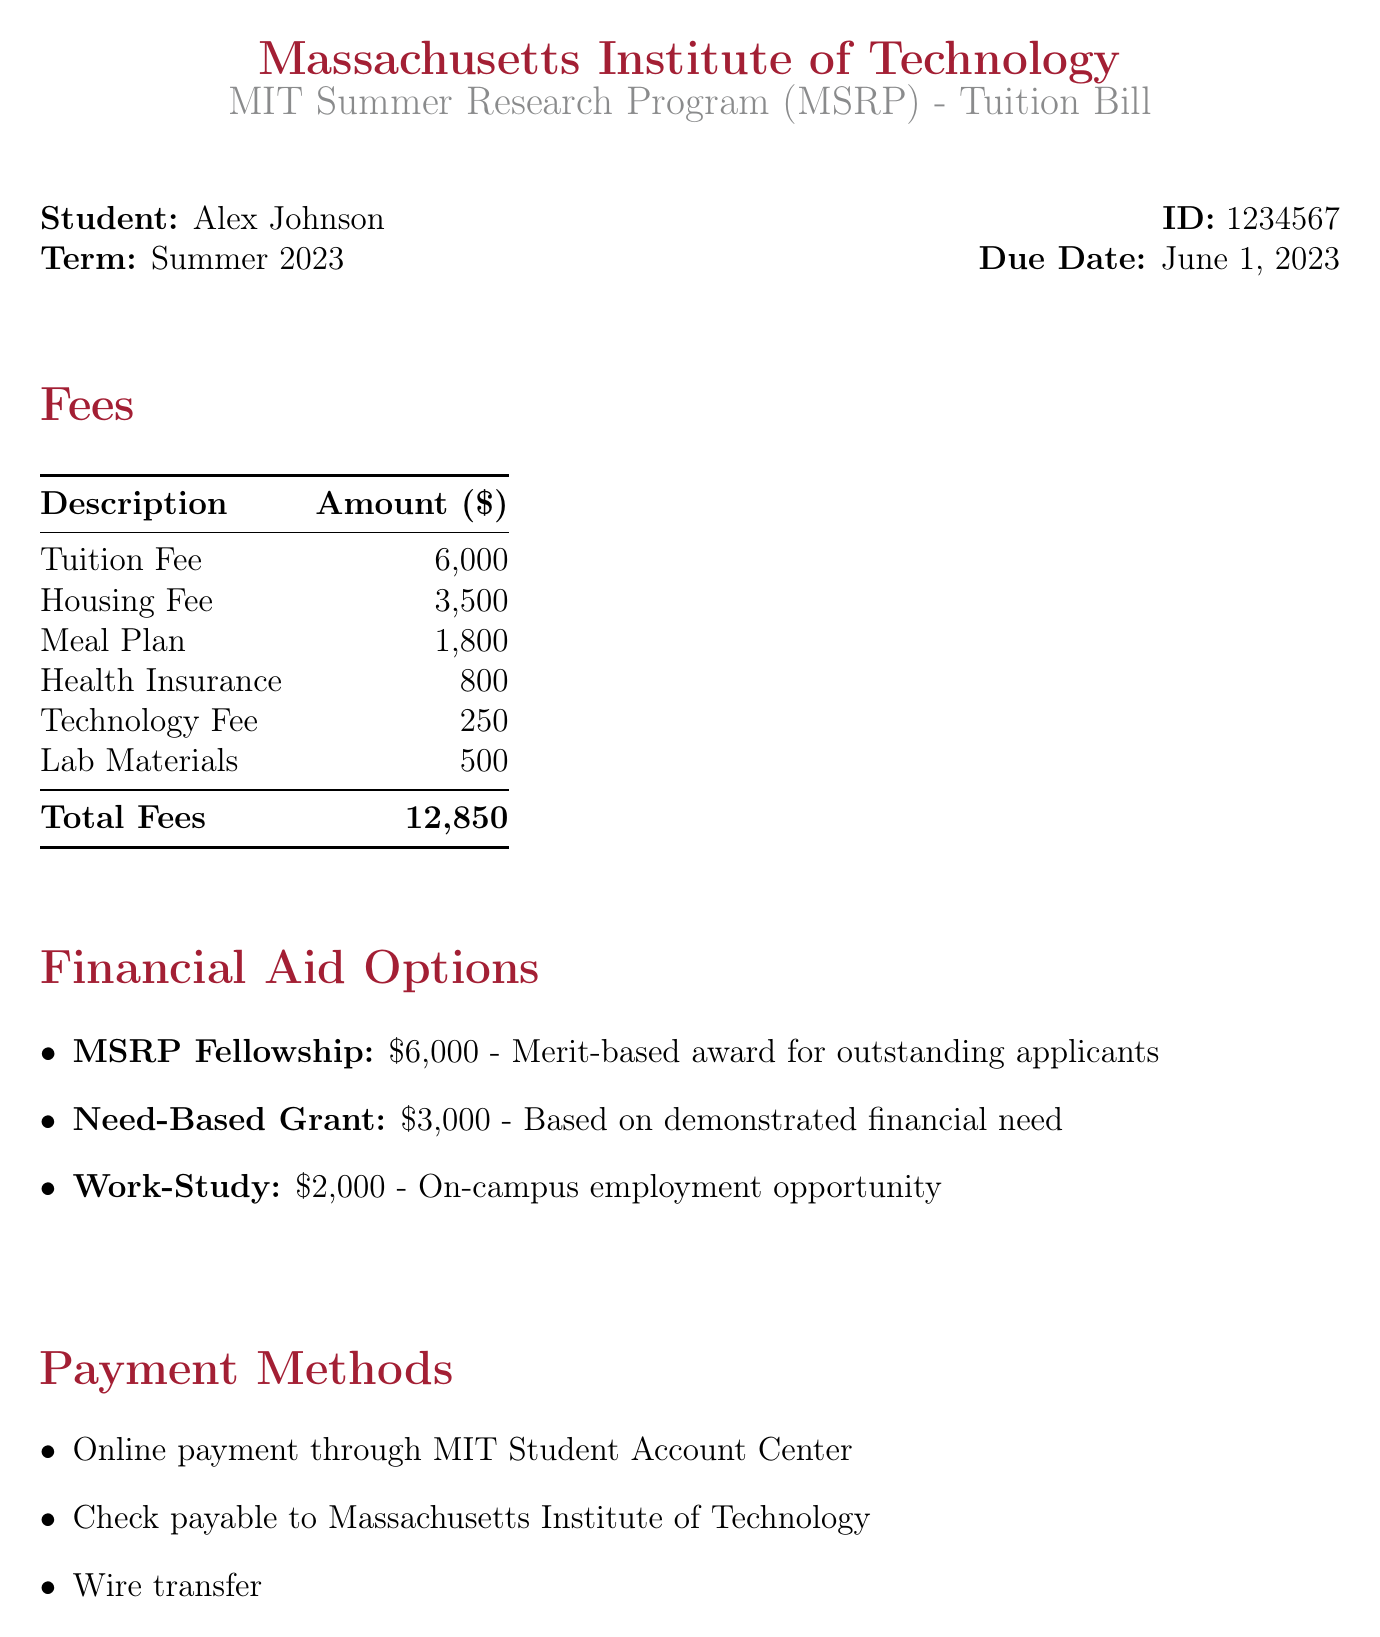What is the tuition fee? The tuition fee is listed directly in the document under "Fees."
Answer: 6000 What is the total amount of fees? This is represented in the "Total Fees" row of the Fees section.
Answer: 12850 What is the due date for the tuition bill? The due date is specified in the introductory section of the document.
Answer: June 1, 2023 What is the amount of the MSRP Fellowship? The MSRP Fellowship amount is mentioned under Financial Aid Options.
Answer: 6000 What is the purpose of the Need-Based Grant? The purpose is indicated in the description under Financial Aid Options, which mentions it is based on financial need.
Answer: Based on demonstrated financial need How can payments be made? The document lists methods for payments in the "Payment Methods" section.
Answer: Online payment, check, wire transfer How much can a student earn through Work-Study? The earning amount for Work-Study is indicated in the Financial Aid Options section.
Answer: 2000 Who should be contacted for more information? The contact information for inquiries is listed under the "Contact Information" section.
Answer: Student Financial Services What color represents the MIT branding in this document? The document specifies a color code in the preamble for use in headings and important text.
Answer: MIT red 